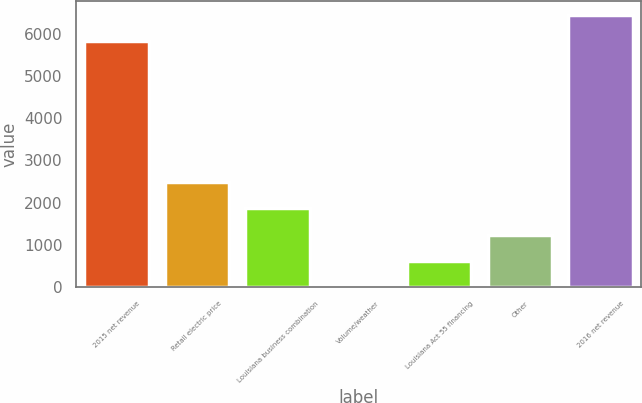Convert chart. <chart><loc_0><loc_0><loc_500><loc_500><bar_chart><fcel>2015 net revenue<fcel>Retail electric price<fcel>Louisiana business combination<fcel>Volume/weather<fcel>Louisiana Act 55 financing<fcel>Other<fcel>2016 net revenue<nl><fcel>5829<fcel>2480<fcel>1863.5<fcel>14<fcel>630.5<fcel>1247<fcel>6445.5<nl></chart> 